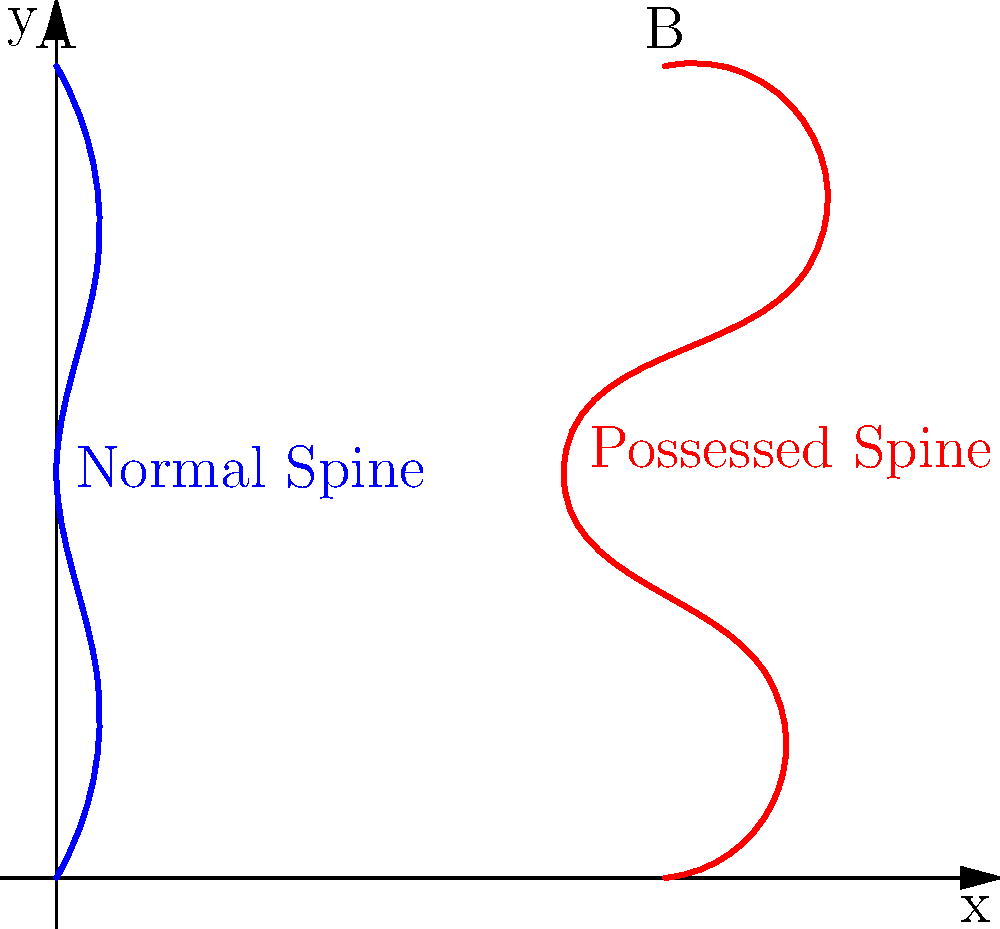In the skeletal diagrams above, which spine (A or B) would likely experience greater shear forces at the intervertebral joints, and why? Consider the concept of "Running Up That Hill" as a metaphor for the increased stress on the spine. To answer this question, let's break it down step-by-step:

1. Observe the two spine diagrams:
   - Spine A (blue) represents a normal human spine
   - Spine B (red) represents the contorted spine of a person possessed by the Mind Flayer

2. Understand shear forces:
   - Shear forces occur when two parts of a structure slide parallel to each other in opposite directions
   - In spines, shear forces act on the intervertebral discs and facet joints

3. Analyze the curvature:
   - Spine A has a natural S-curve (lordosis and kyphosis)
   - Spine B has exaggerated curves and sharp angles

4. Consider the "Running Up That Hill" metaphor:
   - Imagine the stress on the spine increasing like running uphill
   - The more curved and angled the spine, the steeper the metaphorical hill

5. Compare the two spines:
   - Spine B has more extreme curves and angles
   - These sharp bends create more points where vertebrae are not aligned vertically

6. Apply biomechanical principles:
   - Misaligned vertebrae increase shear forces between them
   - The greater the angle of misalignment, the higher the shear force

7. Conclusion:
   - Spine B (possessed spine) would experience greater shear forces at the intervertebral joints due to its more extreme curvature and misalignment
Answer: Spine B (possessed spine) 